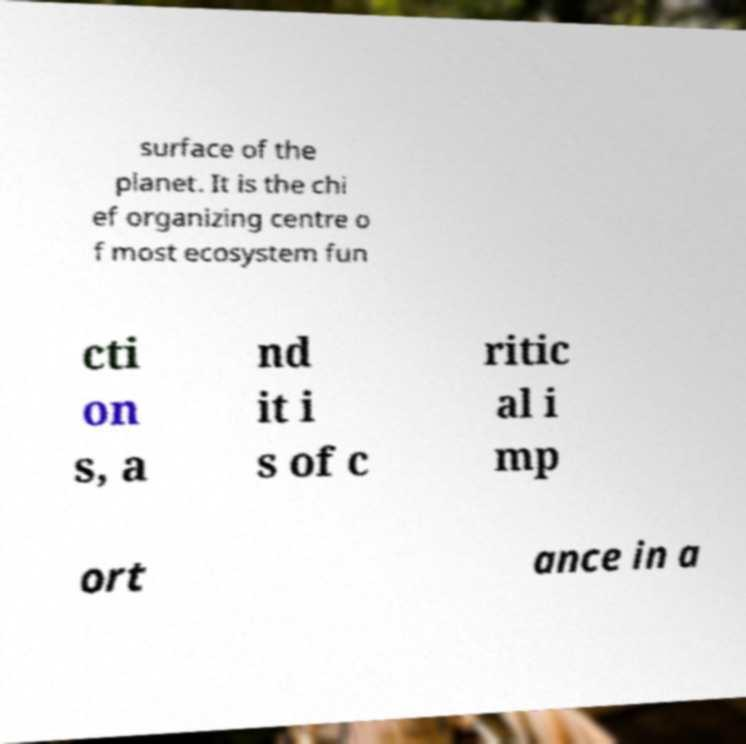Can you accurately transcribe the text from the provided image for me? surface of the planet. It is the chi ef organizing centre o f most ecosystem fun cti on s, a nd it i s of c ritic al i mp ort ance in a 